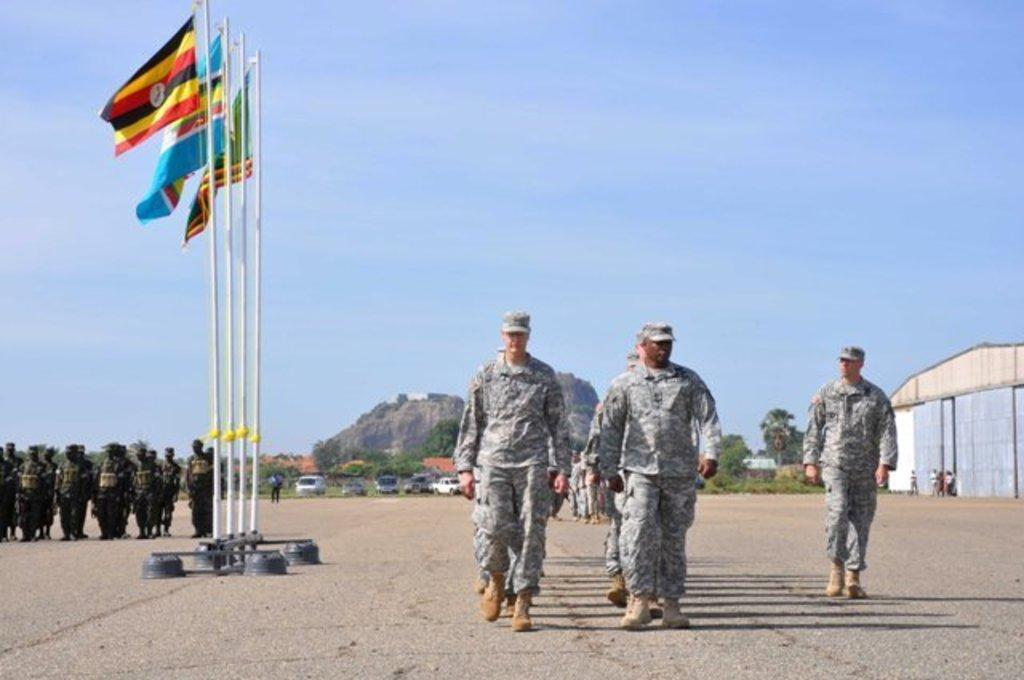How many people are in the image? There is a group of people in the image, but the exact number cannot be determined from the provided facts. What are some of the people in the image doing? Some people are standing, and some are walking on the road. What can be seen in the image besides people? There are flags, vehicles, trees, and the sky visible in the image. What is the background of the image like? The background of the image includes trees and the sky. What type of flesh can be seen hanging from the trees in the image? There is no flesh hanging from the trees in the image; only trees and the sky are visible in the background. 